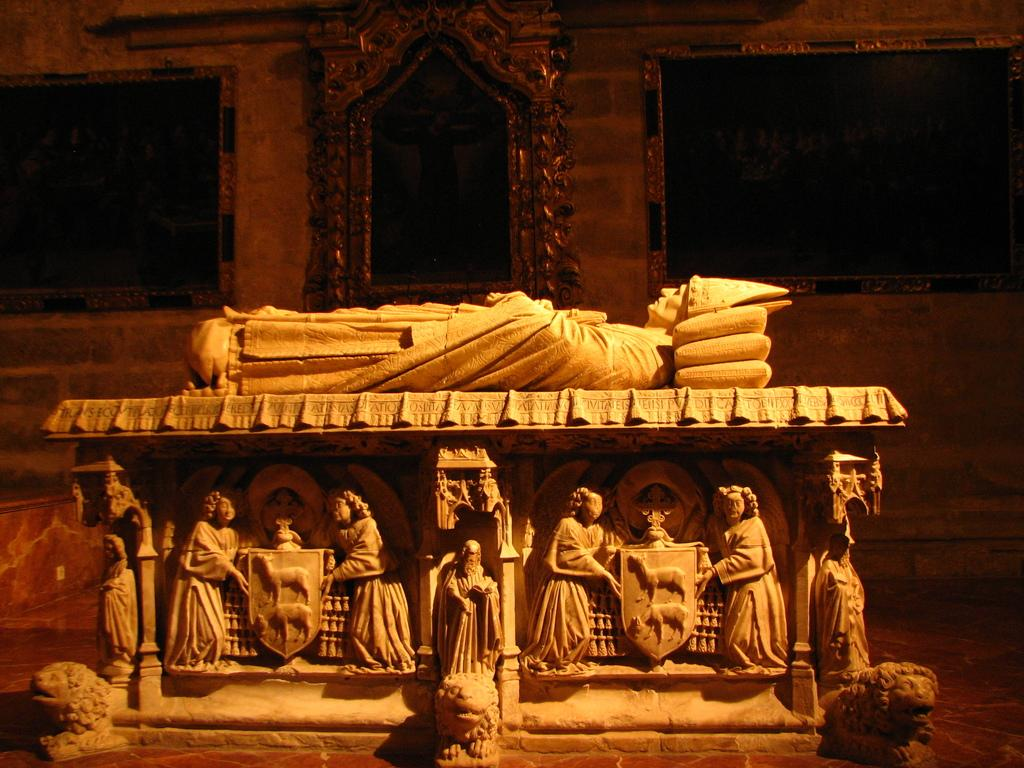What type of artwork can be seen in the image? There are sculptures in the image. How were the sculptures created? The sculptures are carved. What is visible in the background of the image? There is a wall in the background of the image. What can be seen on the wall in the background? There are frames on the wall in the background. What type of net is being used to catch the fish in the image? There are no fish or nets present in the image; it features sculptures and a wall with frames. 